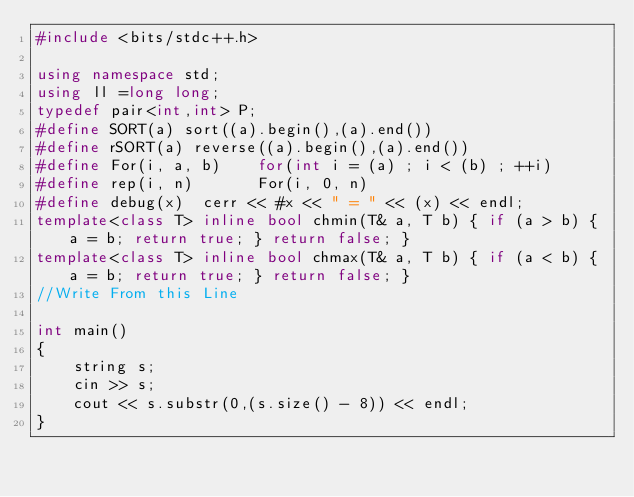Convert code to text. <code><loc_0><loc_0><loc_500><loc_500><_C++_>#include <bits/stdc++.h>

using namespace std;
using ll =long long;
typedef pair<int,int> P;
#define SORT(a) sort((a).begin(),(a).end())
#define rSORT(a) reverse((a).begin(),(a).end())
#define For(i, a, b)    for(int i = (a) ; i < (b) ; ++i)
#define rep(i, n)       For(i, 0, n)
#define debug(x)  cerr << #x << " = " << (x) << endl;
template<class T> inline bool chmin(T& a, T b) { if (a > b) { a = b; return true; } return false; }
template<class T> inline bool chmax(T& a, T b) { if (a < b) { a = b; return true; } return false; }
//Write From this Line

int main()
{
	string s;
	cin >> s;
	cout << s.substr(0,(s.size() - 8)) << endl;
}
</code> 